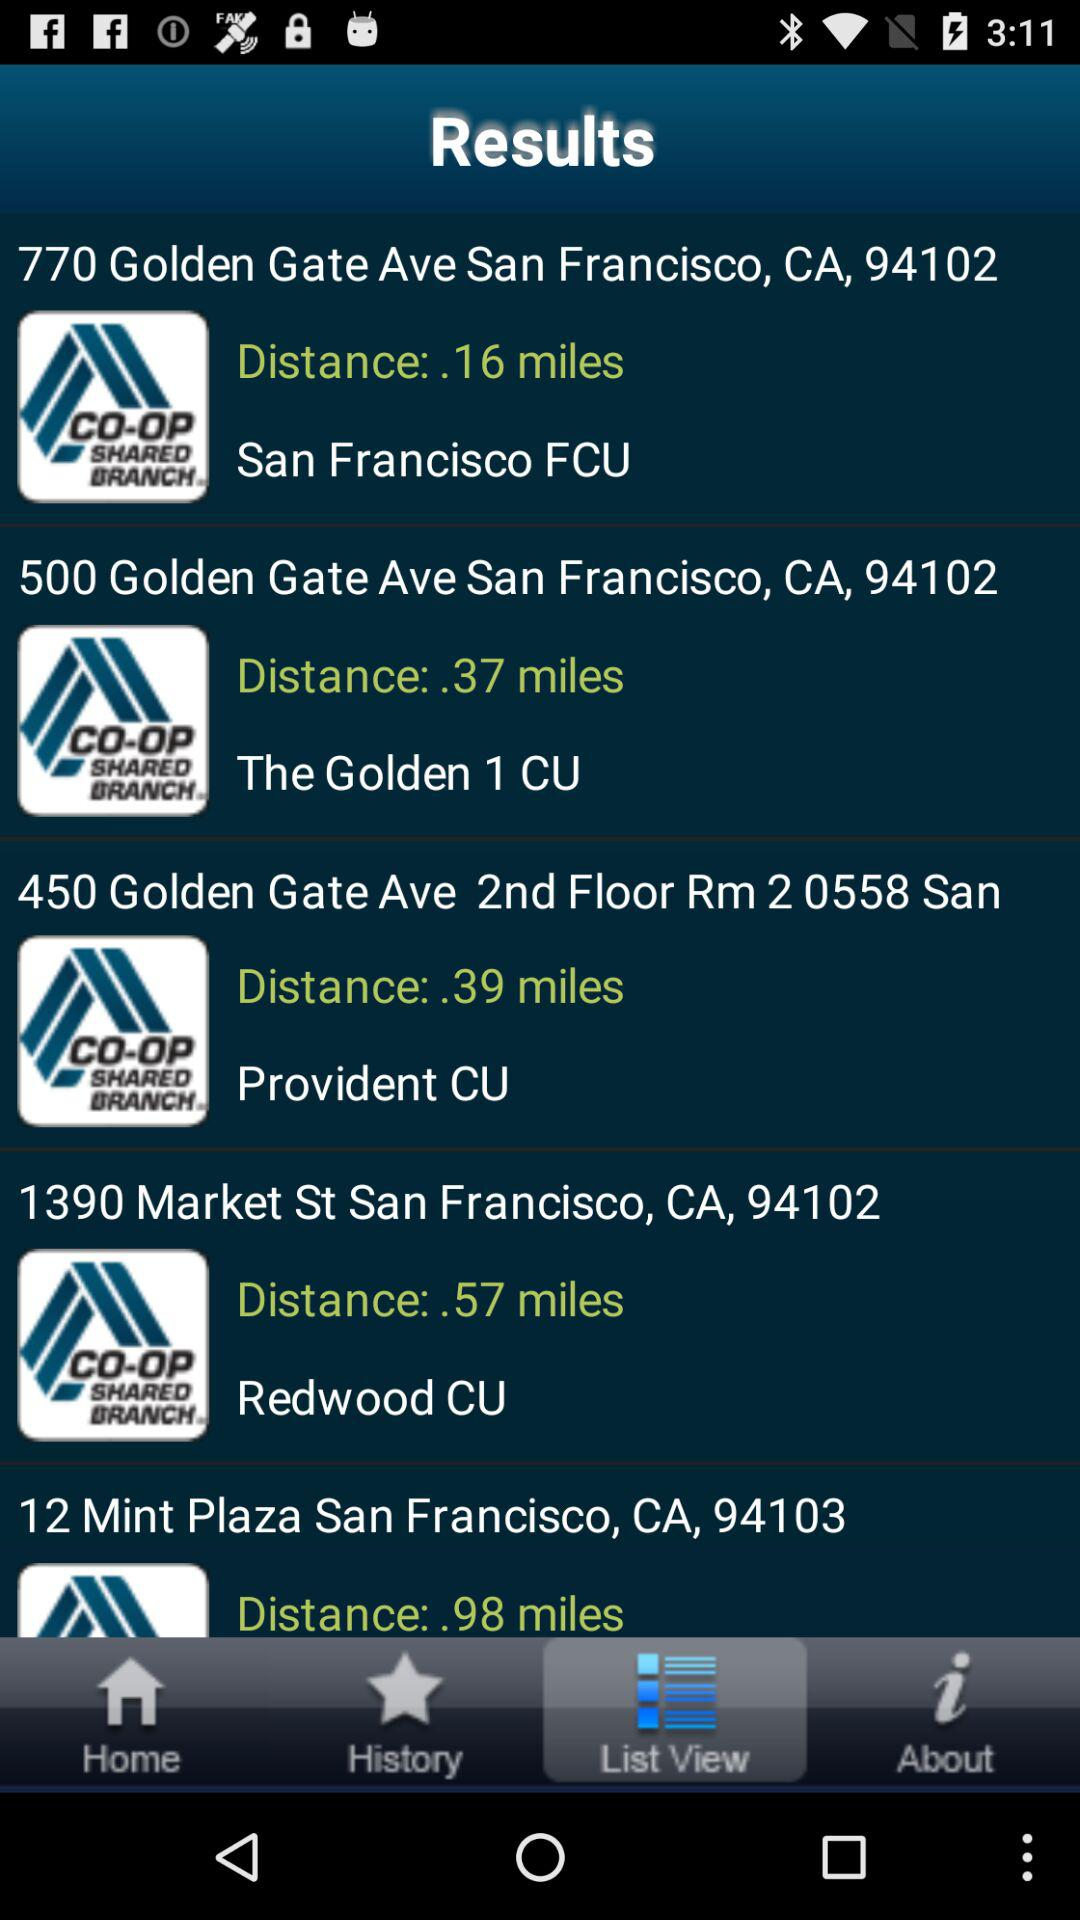Which location is furthest away from the user?
Answer the question using a single word or phrase. 12 Mint Plaza 